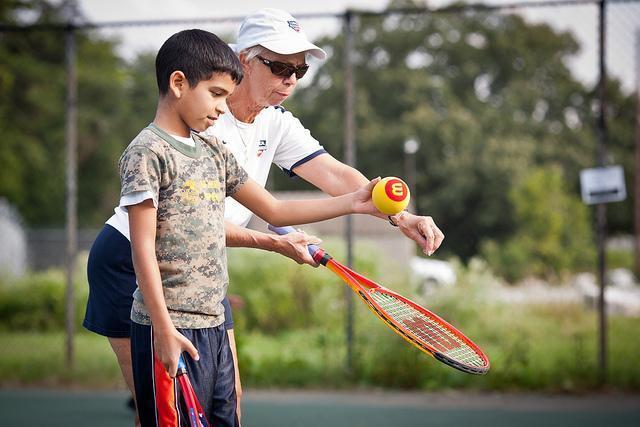How many tennis rackets can you see?
Give a very brief answer. 1. How many people can be seen?
Give a very brief answer. 2. 